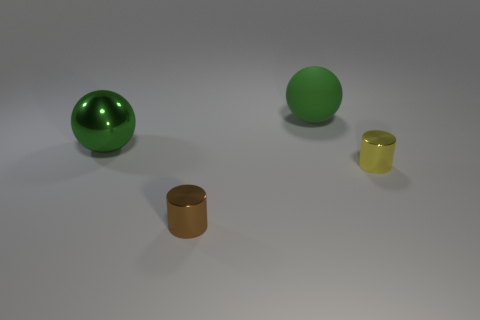Are there an equal number of big balls in front of the big green matte sphere and tiny brown cylinders?
Your answer should be very brief. Yes. Is there a gray metal cube of the same size as the green shiny thing?
Your answer should be very brief. No. Does the yellow object have the same size as the ball right of the metallic sphere?
Your answer should be very brief. No. Are there an equal number of green matte objects behind the large rubber ball and small shiny cylinders left of the green shiny sphere?
Provide a succinct answer. Yes. What is the shape of the large metallic thing that is the same color as the big matte object?
Offer a very short reply. Sphere. There is a small cylinder that is in front of the yellow shiny cylinder; what is it made of?
Offer a very short reply. Metal. Does the green metal thing have the same size as the brown metallic cylinder?
Your response must be concise. No. Is the number of large green objects that are to the left of the tiny brown thing greater than the number of brown metallic things?
Provide a succinct answer. No. What size is the ball that is the same material as the brown thing?
Provide a succinct answer. Large. Are there any tiny things in front of the brown metal cylinder?
Provide a short and direct response. No. 